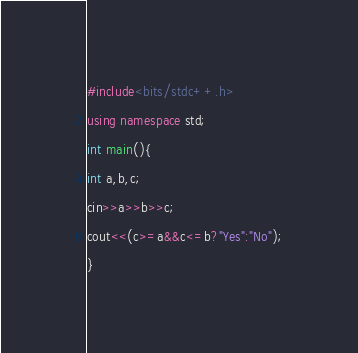<code> <loc_0><loc_0><loc_500><loc_500><_C++_>#include<bits/stdc++.h>
using namespace std;
int main(){
int a,b,c;
cin>>a>>b>>c;
cout<<(c>=a&&c<=b?"Yes":"No");
}</code> 